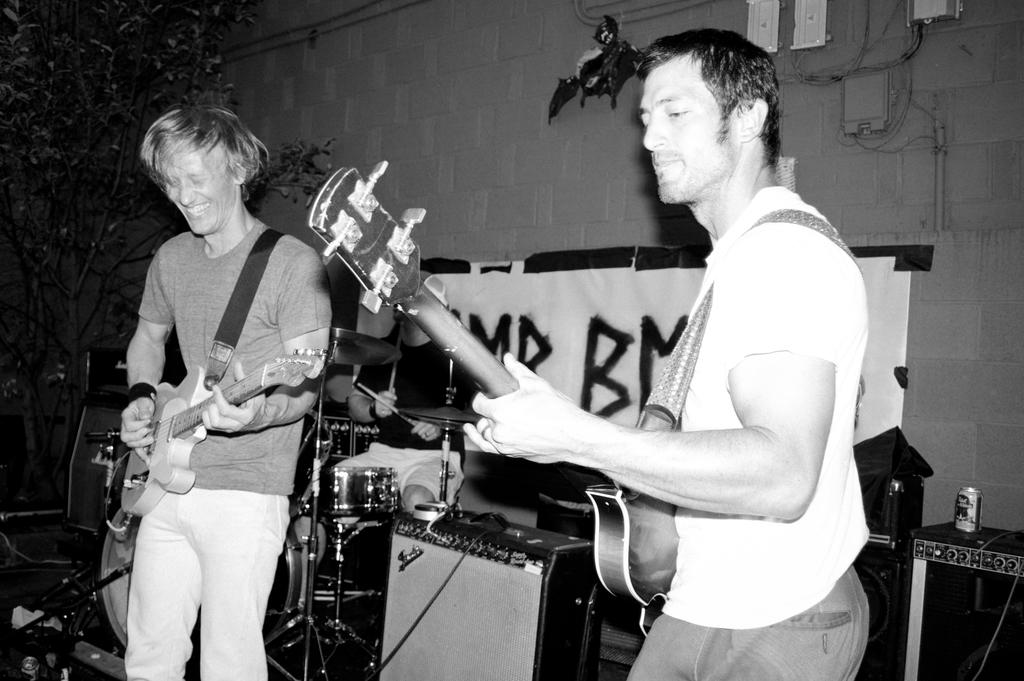How many people are in the image? There are two men in the image. What are the men doing in the image? The men are playing guitar. What can be seen in the background of the image? There are musical instruments, a wall, a banner, and trees in the background. Can you describe an object on the right side of the image? There is a tin on a box on the right side of the image. What type of underwear is the man on the left wearing in the image? There is no information about the men's underwear in the image, so it cannot be determined. What is the tank used for in the image? There is no tank present in the image. 